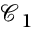Convert formula to latex. <formula><loc_0><loc_0><loc_500><loc_500>\mathcal { C } _ { 1 }</formula> 